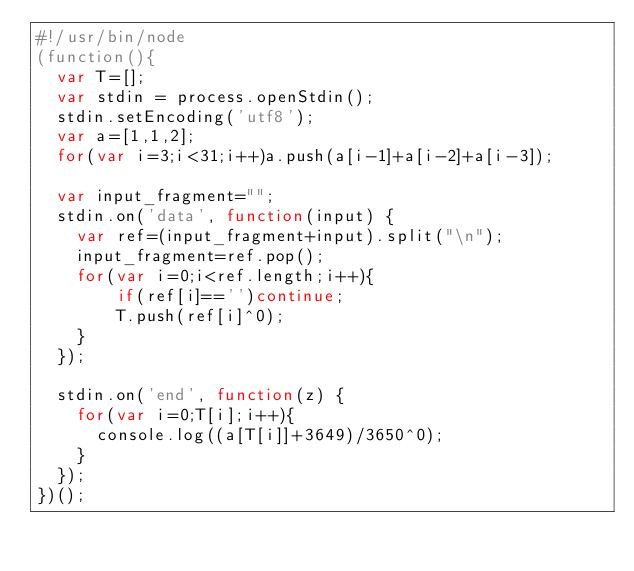<code> <loc_0><loc_0><loc_500><loc_500><_JavaScript_>#!/usr/bin/node
(function(){
  var T=[];
  var stdin = process.openStdin();
  stdin.setEncoding('utf8');
  var a=[1,1,2];
  for(var i=3;i<31;i++)a.push(a[i-1]+a[i-2]+a[i-3]);

  var input_fragment="";
  stdin.on('data', function(input) {
	var ref=(input_fragment+input).split("\n");
	input_fragment=ref.pop();
	for(var i=0;i<ref.length;i++){
		if(ref[i]=='')continue;
		T.push(ref[i]^0);
	}
  });

  stdin.on('end', function(z) {
    for(var i=0;T[i];i++){
      console.log((a[T[i]]+3649)/3650^0);
	}
  });
})();</code> 